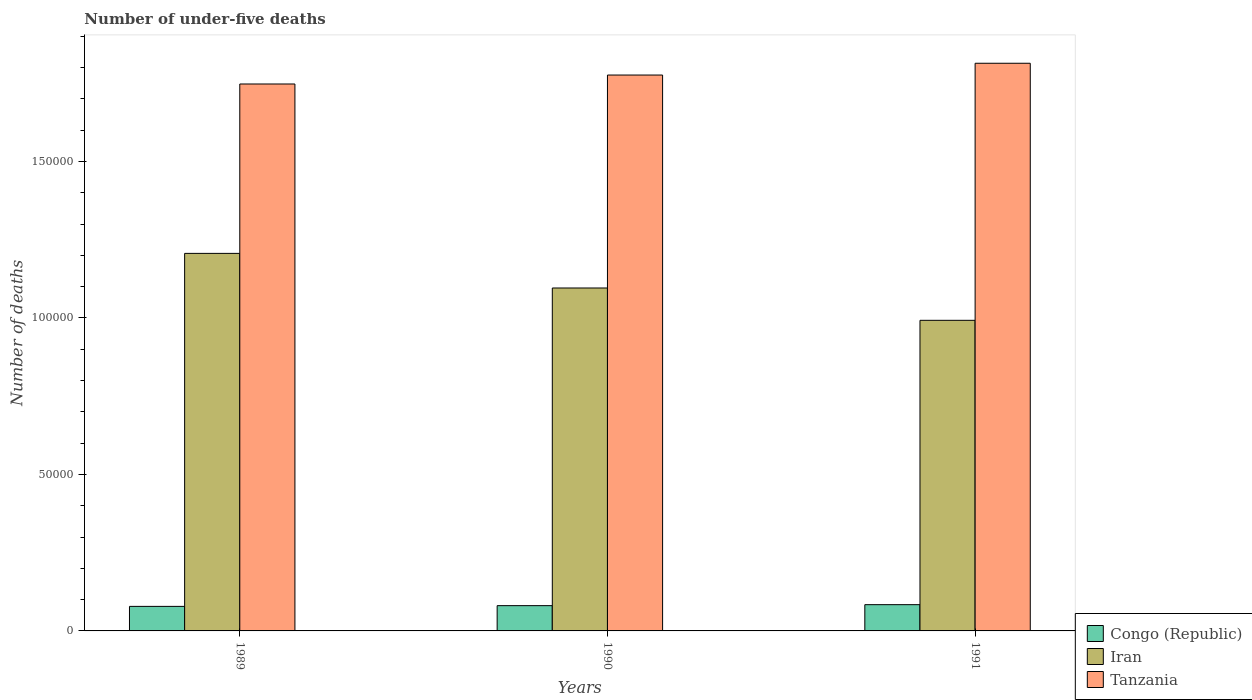How many different coloured bars are there?
Your response must be concise. 3. How many groups of bars are there?
Your response must be concise. 3. Are the number of bars on each tick of the X-axis equal?
Ensure brevity in your answer.  Yes. How many bars are there on the 1st tick from the right?
Keep it short and to the point. 3. What is the number of under-five deaths in Tanzania in 1990?
Give a very brief answer. 1.78e+05. Across all years, what is the maximum number of under-five deaths in Tanzania?
Offer a terse response. 1.81e+05. Across all years, what is the minimum number of under-five deaths in Iran?
Make the answer very short. 9.93e+04. In which year was the number of under-five deaths in Tanzania maximum?
Offer a terse response. 1991. In which year was the number of under-five deaths in Congo (Republic) minimum?
Your answer should be very brief. 1989. What is the total number of under-five deaths in Congo (Republic) in the graph?
Keep it short and to the point. 2.43e+04. What is the difference between the number of under-five deaths in Iran in 1990 and that in 1991?
Ensure brevity in your answer.  1.03e+04. What is the difference between the number of under-five deaths in Tanzania in 1991 and the number of under-five deaths in Congo (Republic) in 1990?
Ensure brevity in your answer.  1.73e+05. What is the average number of under-five deaths in Tanzania per year?
Give a very brief answer. 1.78e+05. In the year 1991, what is the difference between the number of under-five deaths in Congo (Republic) and number of under-five deaths in Iran?
Ensure brevity in your answer.  -9.09e+04. In how many years, is the number of under-five deaths in Congo (Republic) greater than 100000?
Provide a short and direct response. 0. What is the ratio of the number of under-five deaths in Iran in 1990 to that in 1991?
Offer a terse response. 1.1. Is the number of under-five deaths in Iran in 1989 less than that in 1991?
Provide a short and direct response. No. Is the difference between the number of under-five deaths in Congo (Republic) in 1989 and 1990 greater than the difference between the number of under-five deaths in Iran in 1989 and 1990?
Offer a terse response. No. What is the difference between the highest and the second highest number of under-five deaths in Tanzania?
Offer a very short reply. 3764. What is the difference between the highest and the lowest number of under-five deaths in Tanzania?
Your response must be concise. 6628. In how many years, is the number of under-five deaths in Tanzania greater than the average number of under-five deaths in Tanzania taken over all years?
Your response must be concise. 1. What does the 2nd bar from the left in 1991 represents?
Your answer should be very brief. Iran. What does the 1st bar from the right in 1989 represents?
Your response must be concise. Tanzania. Is it the case that in every year, the sum of the number of under-five deaths in Iran and number of under-five deaths in Congo (Republic) is greater than the number of under-five deaths in Tanzania?
Make the answer very short. No. How many bars are there?
Offer a very short reply. 9. Are all the bars in the graph horizontal?
Offer a very short reply. No. How many years are there in the graph?
Give a very brief answer. 3. Are the values on the major ticks of Y-axis written in scientific E-notation?
Make the answer very short. No. Does the graph contain grids?
Offer a very short reply. No. Where does the legend appear in the graph?
Ensure brevity in your answer.  Bottom right. How many legend labels are there?
Ensure brevity in your answer.  3. What is the title of the graph?
Ensure brevity in your answer.  Number of under-five deaths. Does "Dominican Republic" appear as one of the legend labels in the graph?
Offer a very short reply. No. What is the label or title of the X-axis?
Make the answer very short. Years. What is the label or title of the Y-axis?
Your answer should be compact. Number of deaths. What is the Number of deaths in Congo (Republic) in 1989?
Your answer should be very brief. 7841. What is the Number of deaths in Iran in 1989?
Offer a very short reply. 1.21e+05. What is the Number of deaths in Tanzania in 1989?
Provide a succinct answer. 1.75e+05. What is the Number of deaths of Congo (Republic) in 1990?
Ensure brevity in your answer.  8077. What is the Number of deaths in Iran in 1990?
Offer a very short reply. 1.10e+05. What is the Number of deaths in Tanzania in 1990?
Your response must be concise. 1.78e+05. What is the Number of deaths in Congo (Republic) in 1991?
Provide a succinct answer. 8393. What is the Number of deaths in Iran in 1991?
Your response must be concise. 9.93e+04. What is the Number of deaths of Tanzania in 1991?
Offer a very short reply. 1.81e+05. Across all years, what is the maximum Number of deaths of Congo (Republic)?
Give a very brief answer. 8393. Across all years, what is the maximum Number of deaths in Iran?
Give a very brief answer. 1.21e+05. Across all years, what is the maximum Number of deaths of Tanzania?
Provide a short and direct response. 1.81e+05. Across all years, what is the minimum Number of deaths in Congo (Republic)?
Give a very brief answer. 7841. Across all years, what is the minimum Number of deaths of Iran?
Ensure brevity in your answer.  9.93e+04. Across all years, what is the minimum Number of deaths of Tanzania?
Ensure brevity in your answer.  1.75e+05. What is the total Number of deaths in Congo (Republic) in the graph?
Keep it short and to the point. 2.43e+04. What is the total Number of deaths of Iran in the graph?
Your answer should be very brief. 3.29e+05. What is the total Number of deaths in Tanzania in the graph?
Your answer should be compact. 5.34e+05. What is the difference between the Number of deaths of Congo (Republic) in 1989 and that in 1990?
Give a very brief answer. -236. What is the difference between the Number of deaths in Iran in 1989 and that in 1990?
Your answer should be compact. 1.11e+04. What is the difference between the Number of deaths of Tanzania in 1989 and that in 1990?
Your answer should be compact. -2864. What is the difference between the Number of deaths in Congo (Republic) in 1989 and that in 1991?
Offer a terse response. -552. What is the difference between the Number of deaths of Iran in 1989 and that in 1991?
Keep it short and to the point. 2.14e+04. What is the difference between the Number of deaths in Tanzania in 1989 and that in 1991?
Your answer should be very brief. -6628. What is the difference between the Number of deaths in Congo (Republic) in 1990 and that in 1991?
Make the answer very short. -316. What is the difference between the Number of deaths of Iran in 1990 and that in 1991?
Offer a very short reply. 1.03e+04. What is the difference between the Number of deaths in Tanzania in 1990 and that in 1991?
Give a very brief answer. -3764. What is the difference between the Number of deaths in Congo (Republic) in 1989 and the Number of deaths in Iran in 1990?
Offer a very short reply. -1.02e+05. What is the difference between the Number of deaths of Congo (Republic) in 1989 and the Number of deaths of Tanzania in 1990?
Give a very brief answer. -1.70e+05. What is the difference between the Number of deaths of Iran in 1989 and the Number of deaths of Tanzania in 1990?
Provide a short and direct response. -5.70e+04. What is the difference between the Number of deaths of Congo (Republic) in 1989 and the Number of deaths of Iran in 1991?
Keep it short and to the point. -9.14e+04. What is the difference between the Number of deaths of Congo (Republic) in 1989 and the Number of deaths of Tanzania in 1991?
Your answer should be very brief. -1.74e+05. What is the difference between the Number of deaths in Iran in 1989 and the Number of deaths in Tanzania in 1991?
Make the answer very short. -6.08e+04. What is the difference between the Number of deaths of Congo (Republic) in 1990 and the Number of deaths of Iran in 1991?
Provide a succinct answer. -9.12e+04. What is the difference between the Number of deaths of Congo (Republic) in 1990 and the Number of deaths of Tanzania in 1991?
Your response must be concise. -1.73e+05. What is the difference between the Number of deaths of Iran in 1990 and the Number of deaths of Tanzania in 1991?
Ensure brevity in your answer.  -7.18e+04. What is the average Number of deaths of Congo (Republic) per year?
Provide a succinct answer. 8103.67. What is the average Number of deaths in Iran per year?
Provide a succinct answer. 1.10e+05. What is the average Number of deaths of Tanzania per year?
Ensure brevity in your answer.  1.78e+05. In the year 1989, what is the difference between the Number of deaths of Congo (Republic) and Number of deaths of Iran?
Offer a terse response. -1.13e+05. In the year 1989, what is the difference between the Number of deaths in Congo (Republic) and Number of deaths in Tanzania?
Your answer should be compact. -1.67e+05. In the year 1989, what is the difference between the Number of deaths in Iran and Number of deaths in Tanzania?
Offer a terse response. -5.41e+04. In the year 1990, what is the difference between the Number of deaths in Congo (Republic) and Number of deaths in Iran?
Make the answer very short. -1.02e+05. In the year 1990, what is the difference between the Number of deaths of Congo (Republic) and Number of deaths of Tanzania?
Offer a very short reply. -1.70e+05. In the year 1990, what is the difference between the Number of deaths in Iran and Number of deaths in Tanzania?
Provide a short and direct response. -6.80e+04. In the year 1991, what is the difference between the Number of deaths of Congo (Republic) and Number of deaths of Iran?
Your answer should be compact. -9.09e+04. In the year 1991, what is the difference between the Number of deaths in Congo (Republic) and Number of deaths in Tanzania?
Ensure brevity in your answer.  -1.73e+05. In the year 1991, what is the difference between the Number of deaths of Iran and Number of deaths of Tanzania?
Provide a short and direct response. -8.21e+04. What is the ratio of the Number of deaths of Congo (Republic) in 1989 to that in 1990?
Give a very brief answer. 0.97. What is the ratio of the Number of deaths of Iran in 1989 to that in 1990?
Offer a terse response. 1.1. What is the ratio of the Number of deaths in Tanzania in 1989 to that in 1990?
Your response must be concise. 0.98. What is the ratio of the Number of deaths of Congo (Republic) in 1989 to that in 1991?
Provide a short and direct response. 0.93. What is the ratio of the Number of deaths of Iran in 1989 to that in 1991?
Provide a short and direct response. 1.22. What is the ratio of the Number of deaths in Tanzania in 1989 to that in 1991?
Ensure brevity in your answer.  0.96. What is the ratio of the Number of deaths of Congo (Republic) in 1990 to that in 1991?
Give a very brief answer. 0.96. What is the ratio of the Number of deaths of Iran in 1990 to that in 1991?
Your answer should be compact. 1.1. What is the ratio of the Number of deaths in Tanzania in 1990 to that in 1991?
Make the answer very short. 0.98. What is the difference between the highest and the second highest Number of deaths in Congo (Republic)?
Keep it short and to the point. 316. What is the difference between the highest and the second highest Number of deaths in Iran?
Provide a succinct answer. 1.11e+04. What is the difference between the highest and the second highest Number of deaths in Tanzania?
Keep it short and to the point. 3764. What is the difference between the highest and the lowest Number of deaths in Congo (Republic)?
Your answer should be very brief. 552. What is the difference between the highest and the lowest Number of deaths of Iran?
Provide a short and direct response. 2.14e+04. What is the difference between the highest and the lowest Number of deaths of Tanzania?
Keep it short and to the point. 6628. 